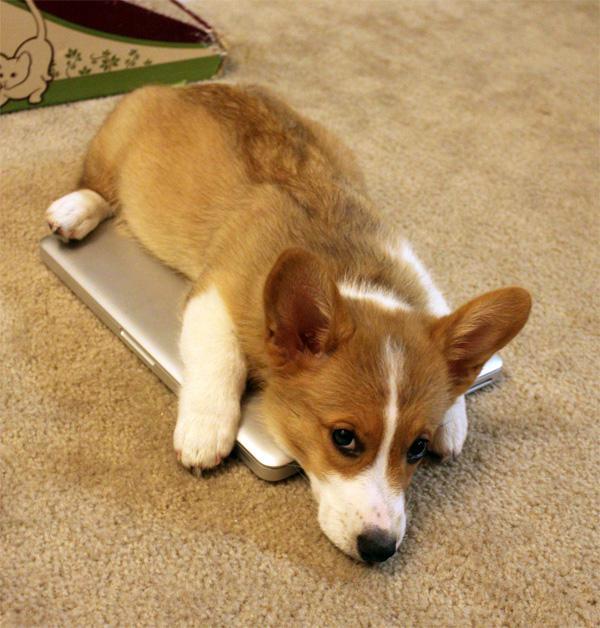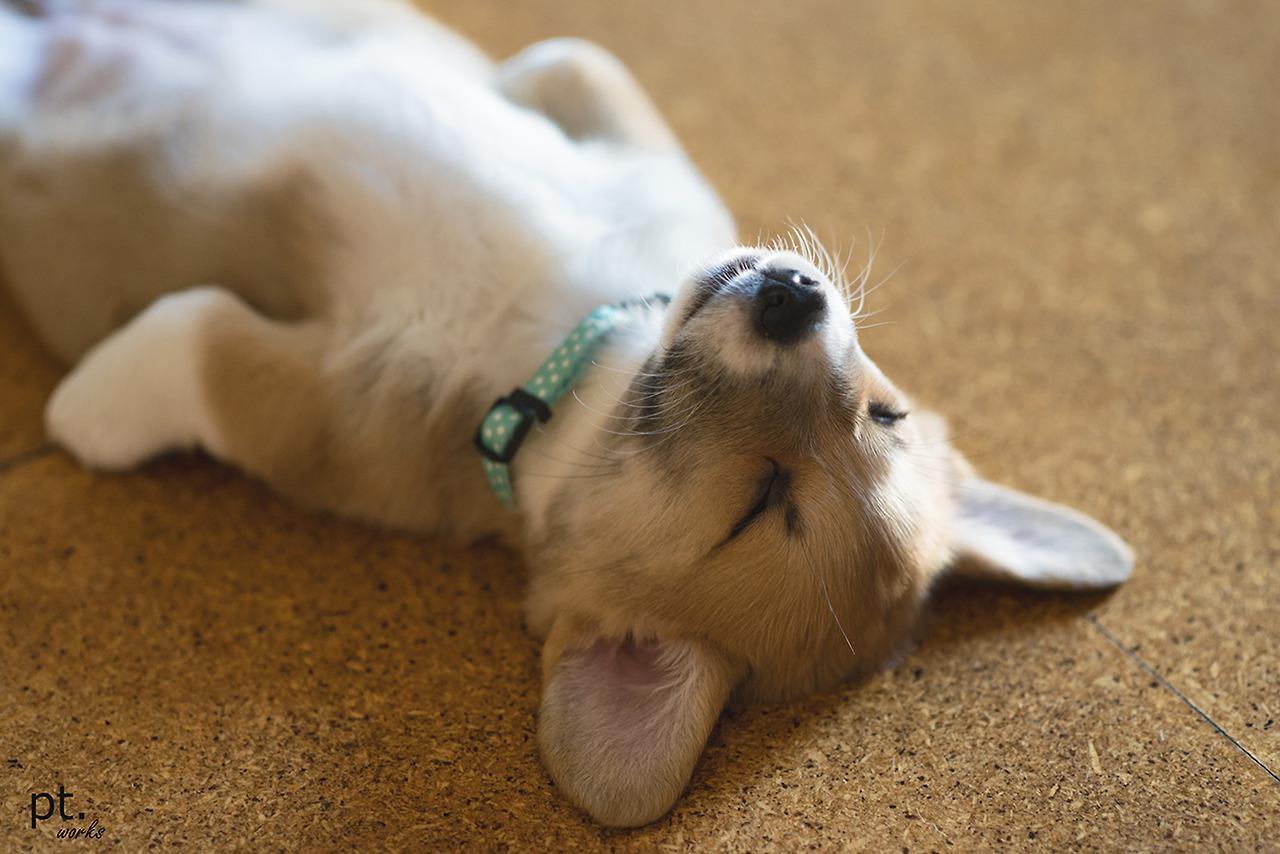The first image is the image on the left, the second image is the image on the right. Considering the images on both sides, is "At least one puppy is outside." valid? Answer yes or no. No. The first image is the image on the left, the second image is the image on the right. Assess this claim about the two images: "At least one pup is outside.". Correct or not? Answer yes or no. No. 